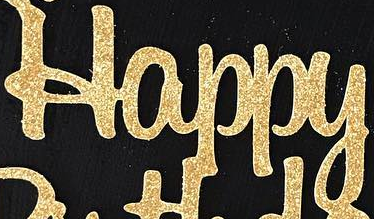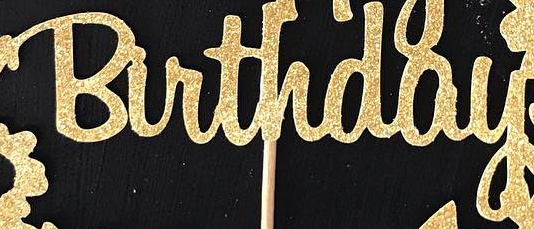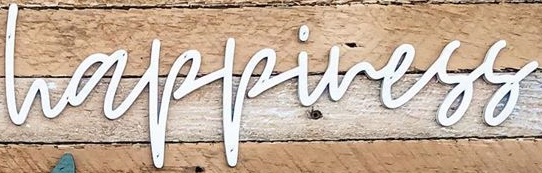What words are shown in these images in order, separated by a semicolon? Happy; Birthday; happiness 